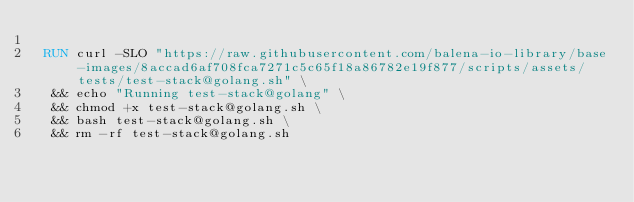Convert code to text. <code><loc_0><loc_0><loc_500><loc_500><_Dockerfile_>
 RUN curl -SLO "https://raw.githubusercontent.com/balena-io-library/base-images/8accad6af708fca7271c5c65f18a86782e19f877/scripts/assets/tests/test-stack@golang.sh" \
  && echo "Running test-stack@golang" \
  && chmod +x test-stack@golang.sh \
  && bash test-stack@golang.sh \
  && rm -rf test-stack@golang.sh 
</code> 